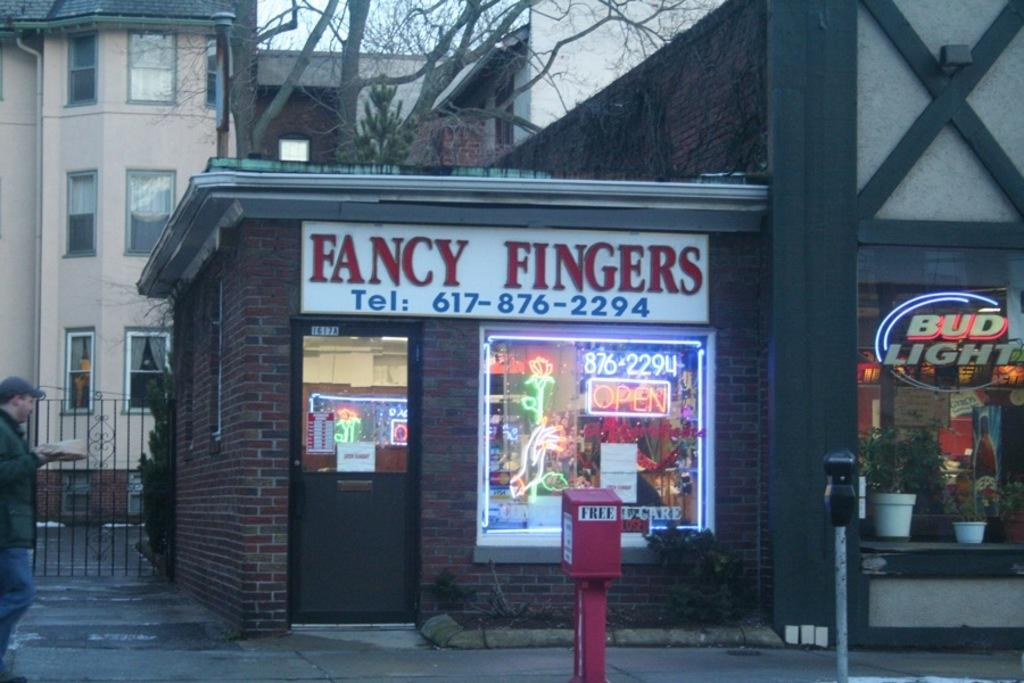<image>
Give a short and clear explanation of the subsequent image. A store called Fancy Fingers with a red box labeled free in front of it. 